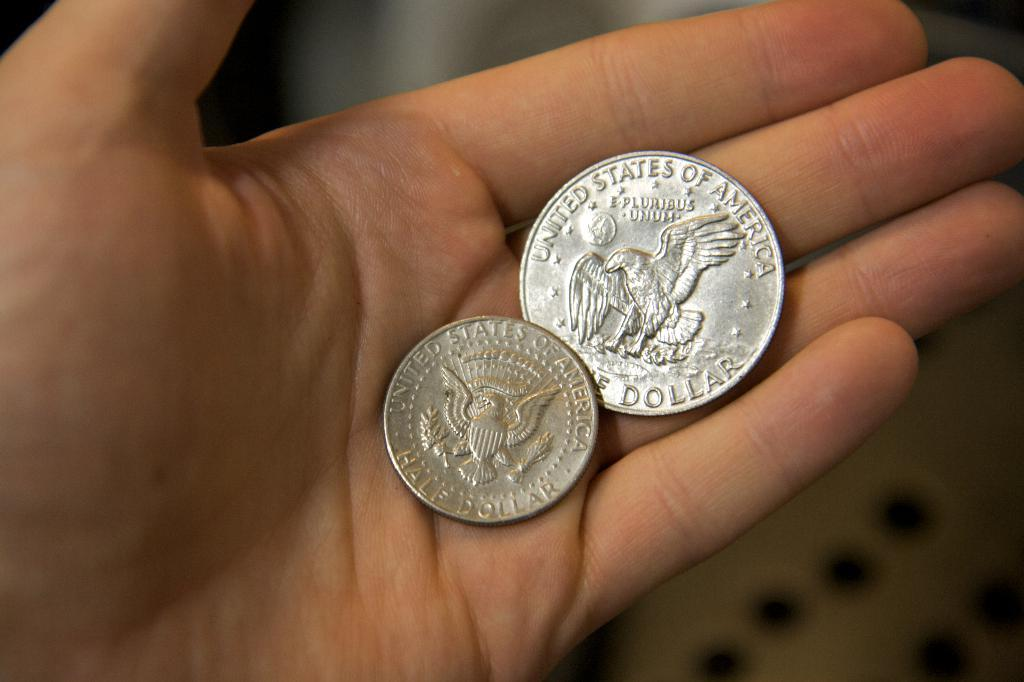<image>
Present a compact description of the photo's key features. A hand is holding two different sized United States of America half dollars. 